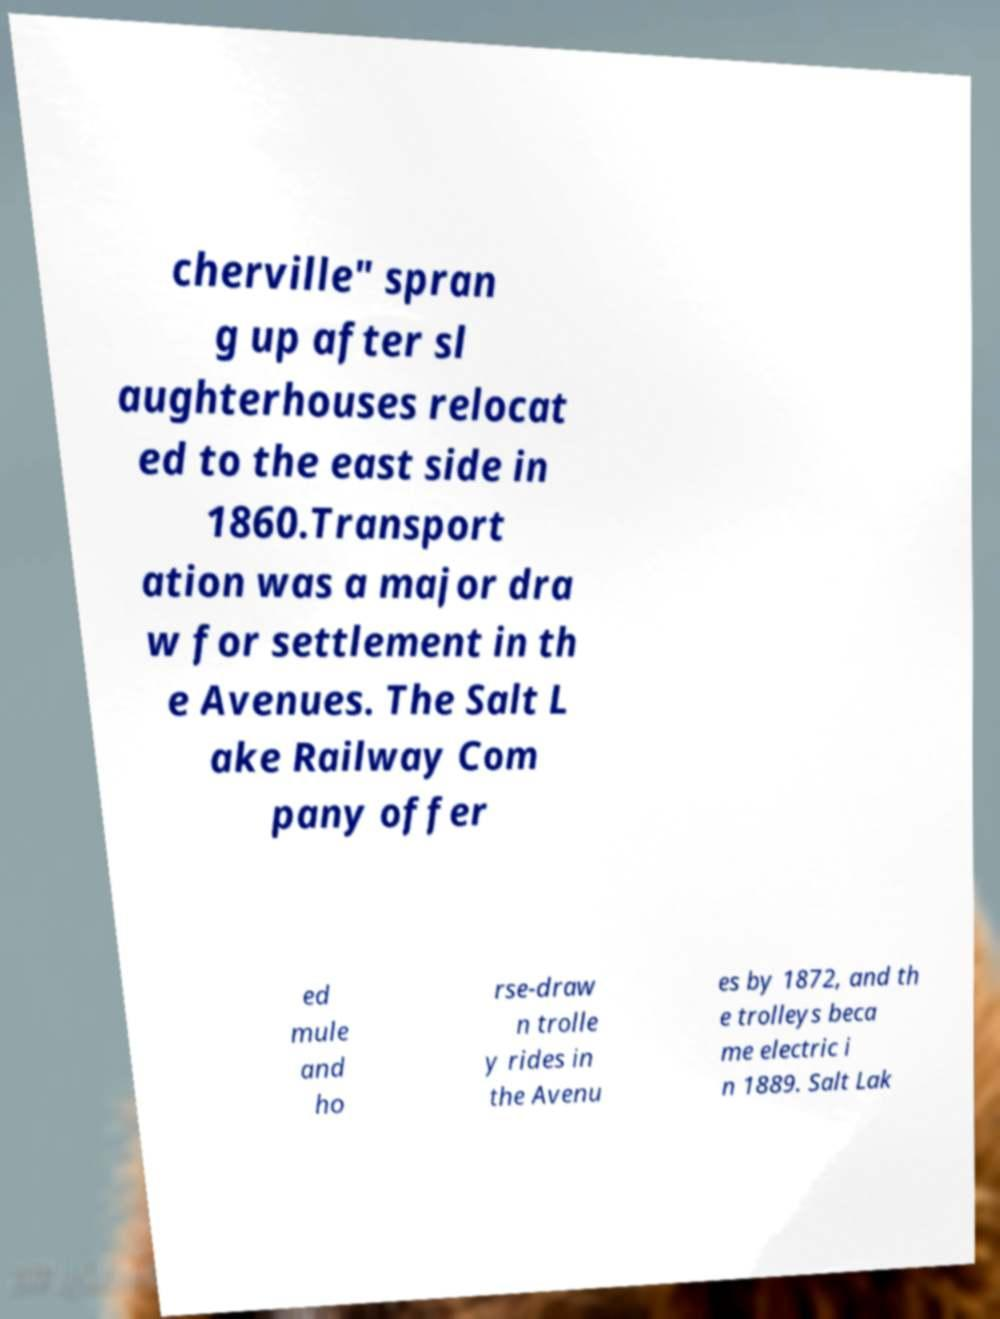I need the written content from this picture converted into text. Can you do that? cherville" spran g up after sl aughterhouses relocat ed to the east side in 1860.Transport ation was a major dra w for settlement in th e Avenues. The Salt L ake Railway Com pany offer ed mule and ho rse-draw n trolle y rides in the Avenu es by 1872, and th e trolleys beca me electric i n 1889. Salt Lak 